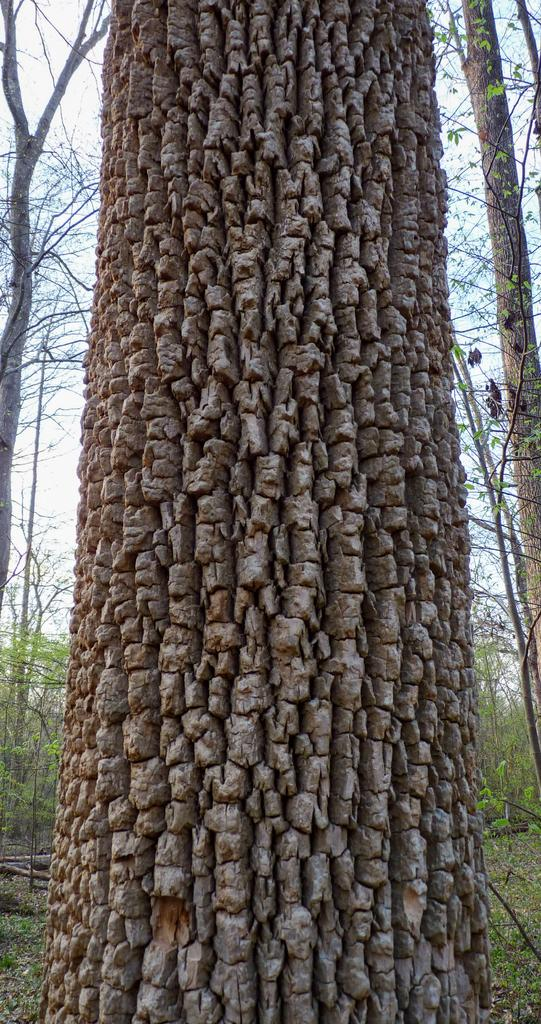What type of surface can be seen at the bottom of the image? The ground is visible in the image. What type of vegetation is present in the image? There are plants and trees in the image. Can you describe the trunk of a tree that is visible? The trunk of a tree is visible in the image. What is visible in the background of the image? The sky is visible in the image. What type of vegetation covers the ground in the image? There is grass in the image. What word does the aunt say in the image? There is no mention of an aunt or any spoken words in the image. 